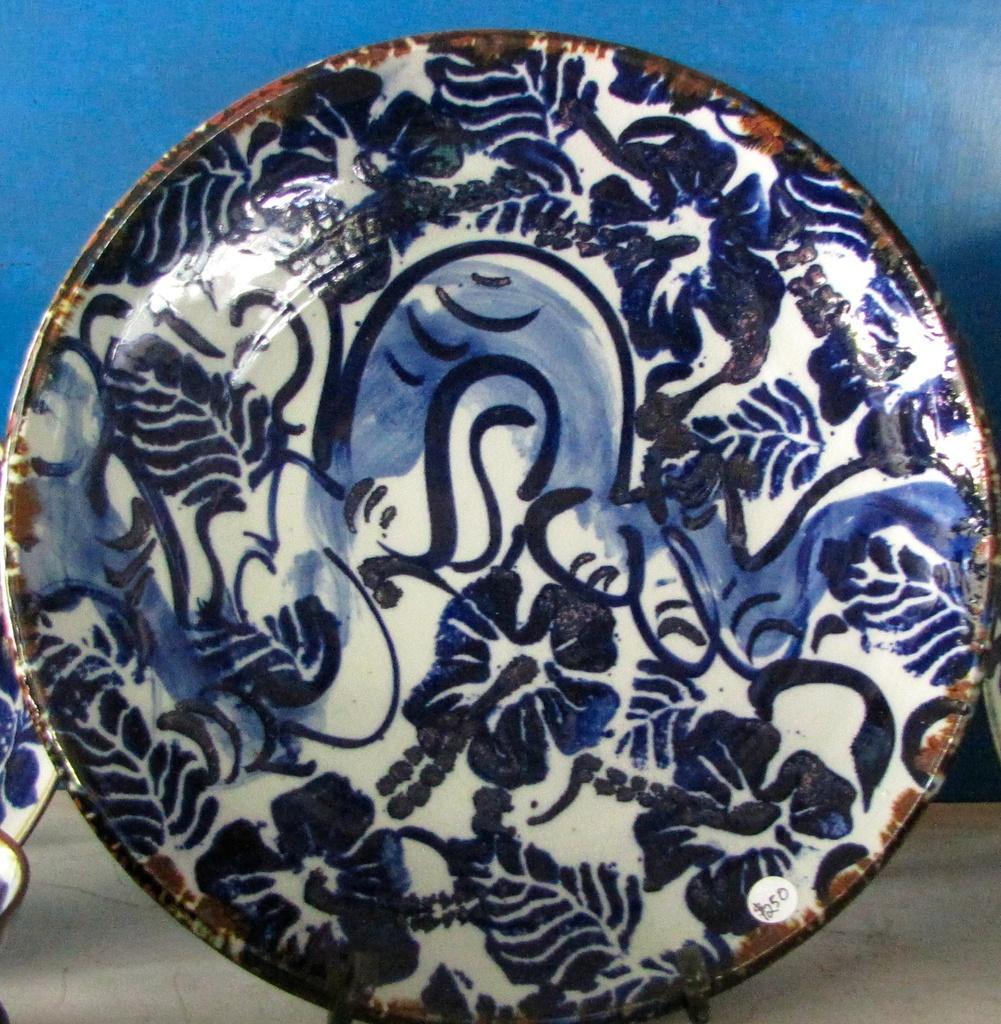In one or two sentences, can you explain what this image depicts? In this image in front there are plates on the floor. In the background of the image there is a wall. 